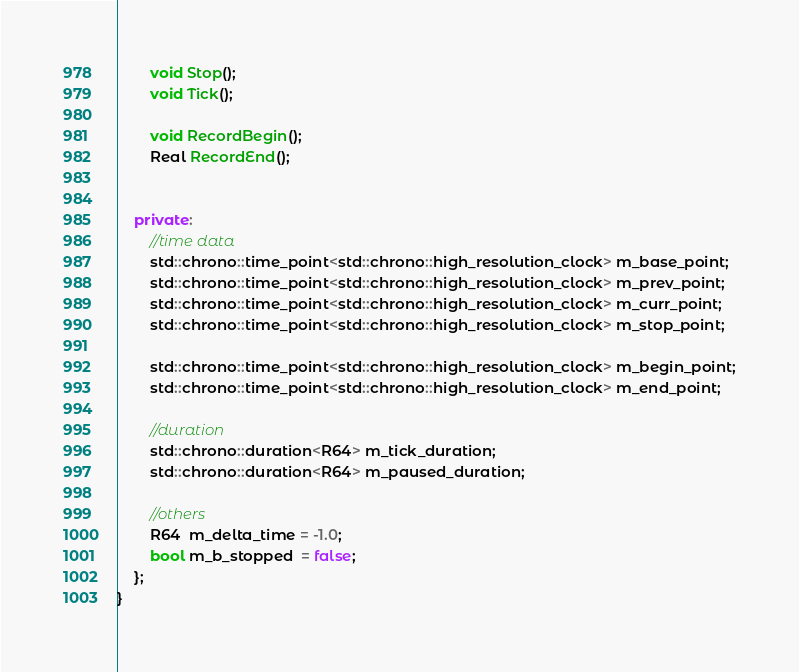<code> <loc_0><loc_0><loc_500><loc_500><_C++_>        void Stop();
        void Tick();

        void RecordBegin();
        Real RecordEnd();
        

    private:
        //time data
        std::chrono::time_point<std::chrono::high_resolution_clock> m_base_point;
        std::chrono::time_point<std::chrono::high_resolution_clock> m_prev_point;
        std::chrono::time_point<std::chrono::high_resolution_clock> m_curr_point;
        std::chrono::time_point<std::chrono::high_resolution_clock> m_stop_point;

        std::chrono::time_point<std::chrono::high_resolution_clock> m_begin_point;
        std::chrono::time_point<std::chrono::high_resolution_clock> m_end_point;

        //duration
        std::chrono::duration<R64> m_tick_duration;
        std::chrono::duration<R64> m_paused_duration;

        //others
        R64  m_delta_time = -1.0;
        bool m_b_stopped  = false;
    };
}
</code> 